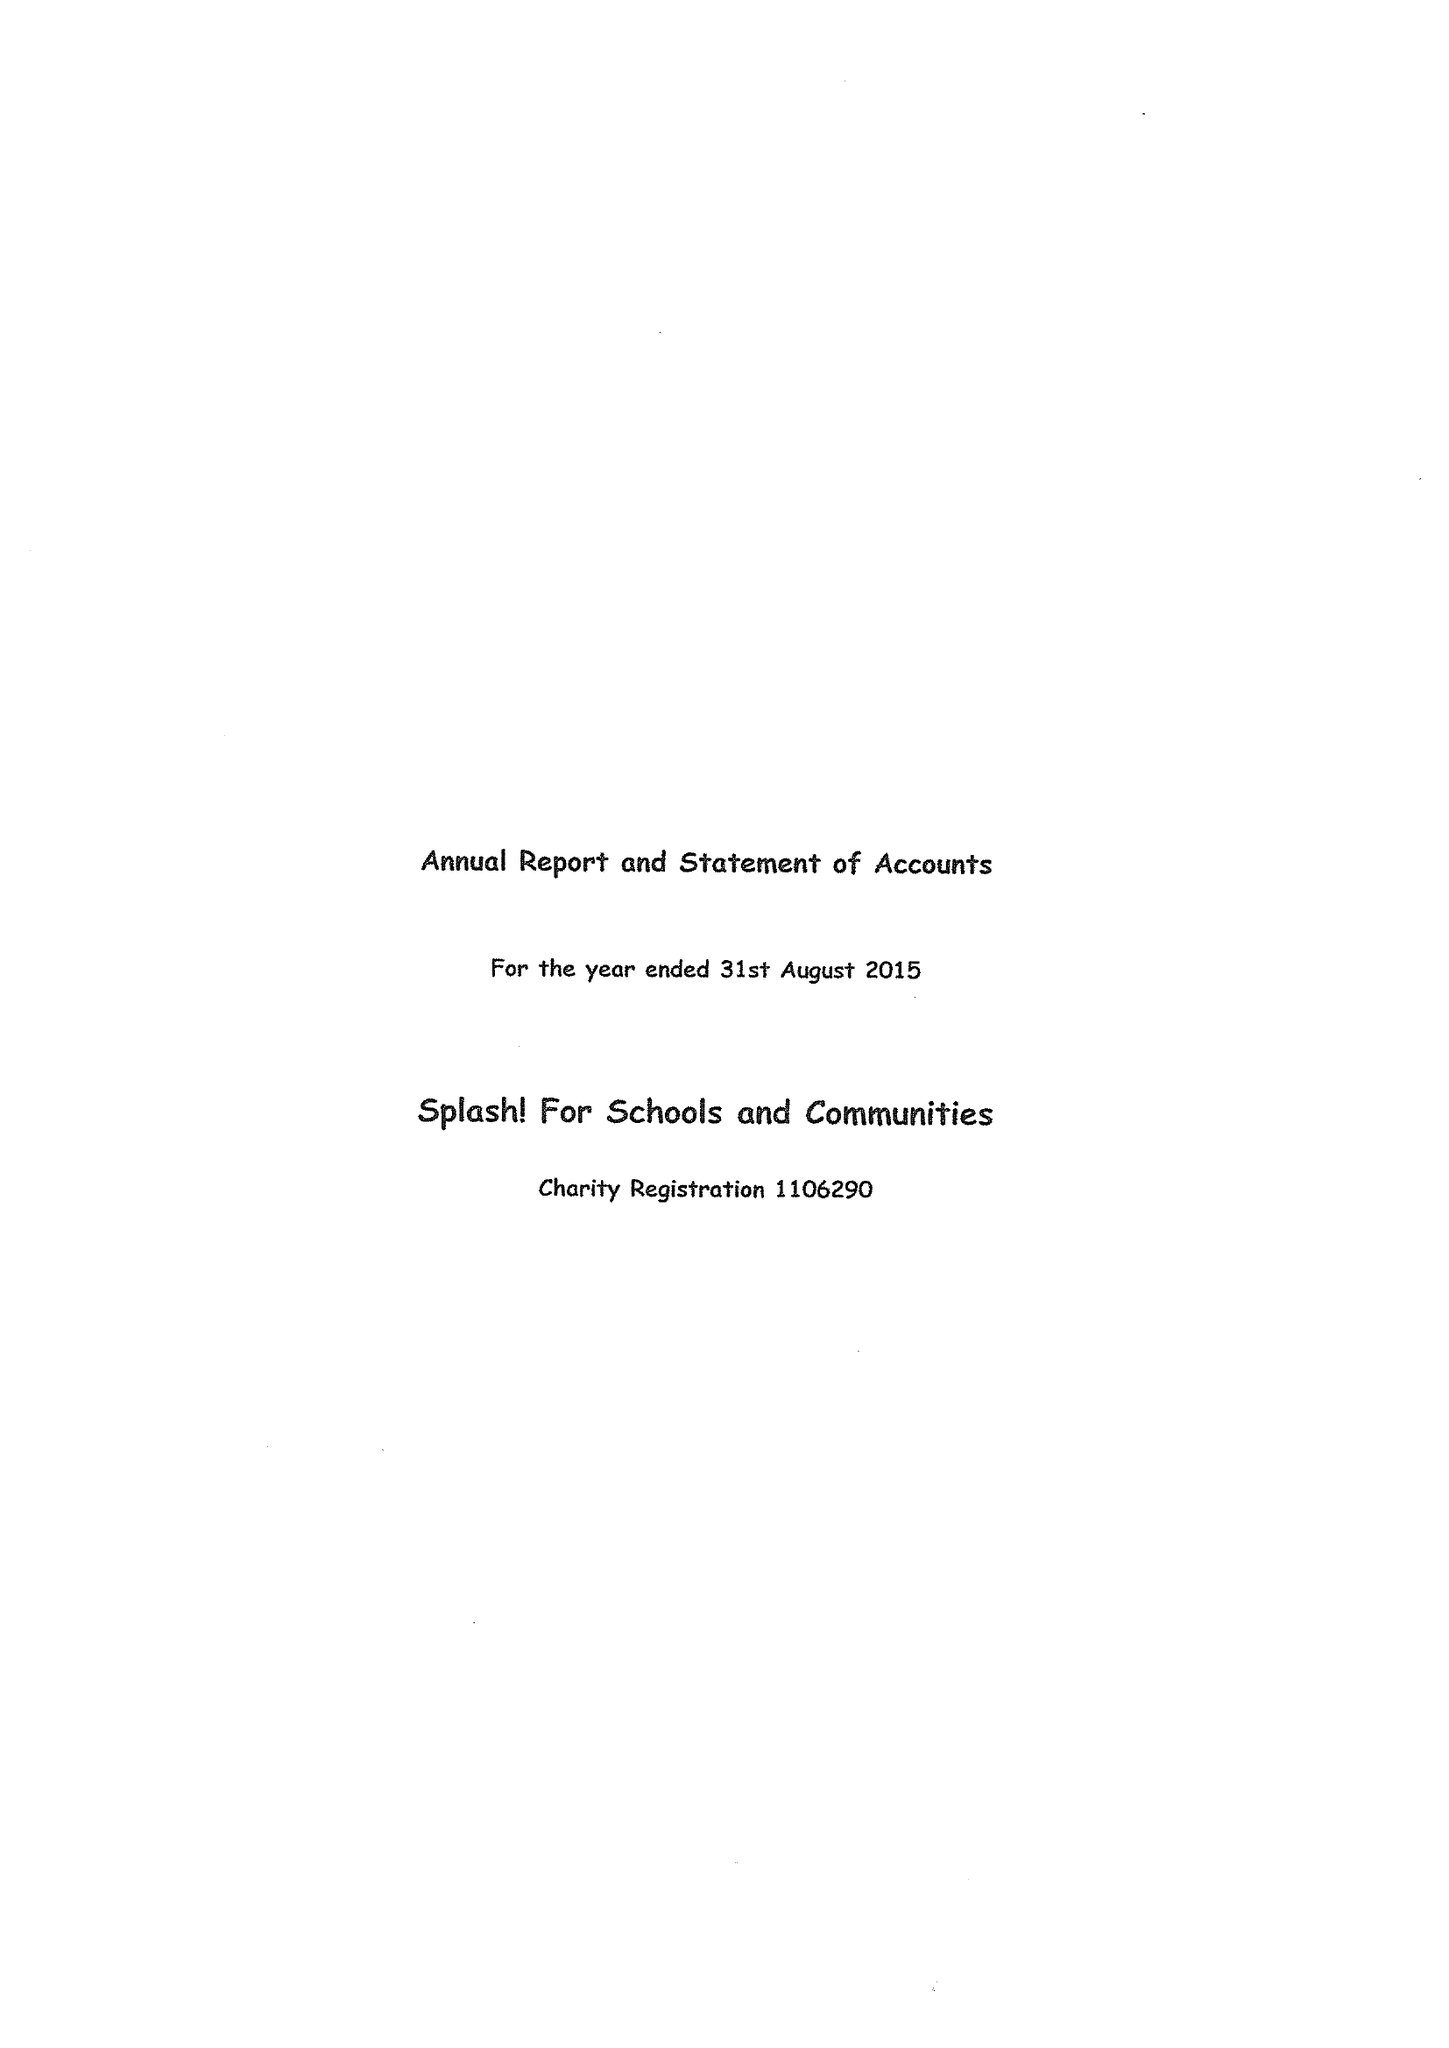What is the value for the report_date?
Answer the question using a single word or phrase. 2015-08-31 